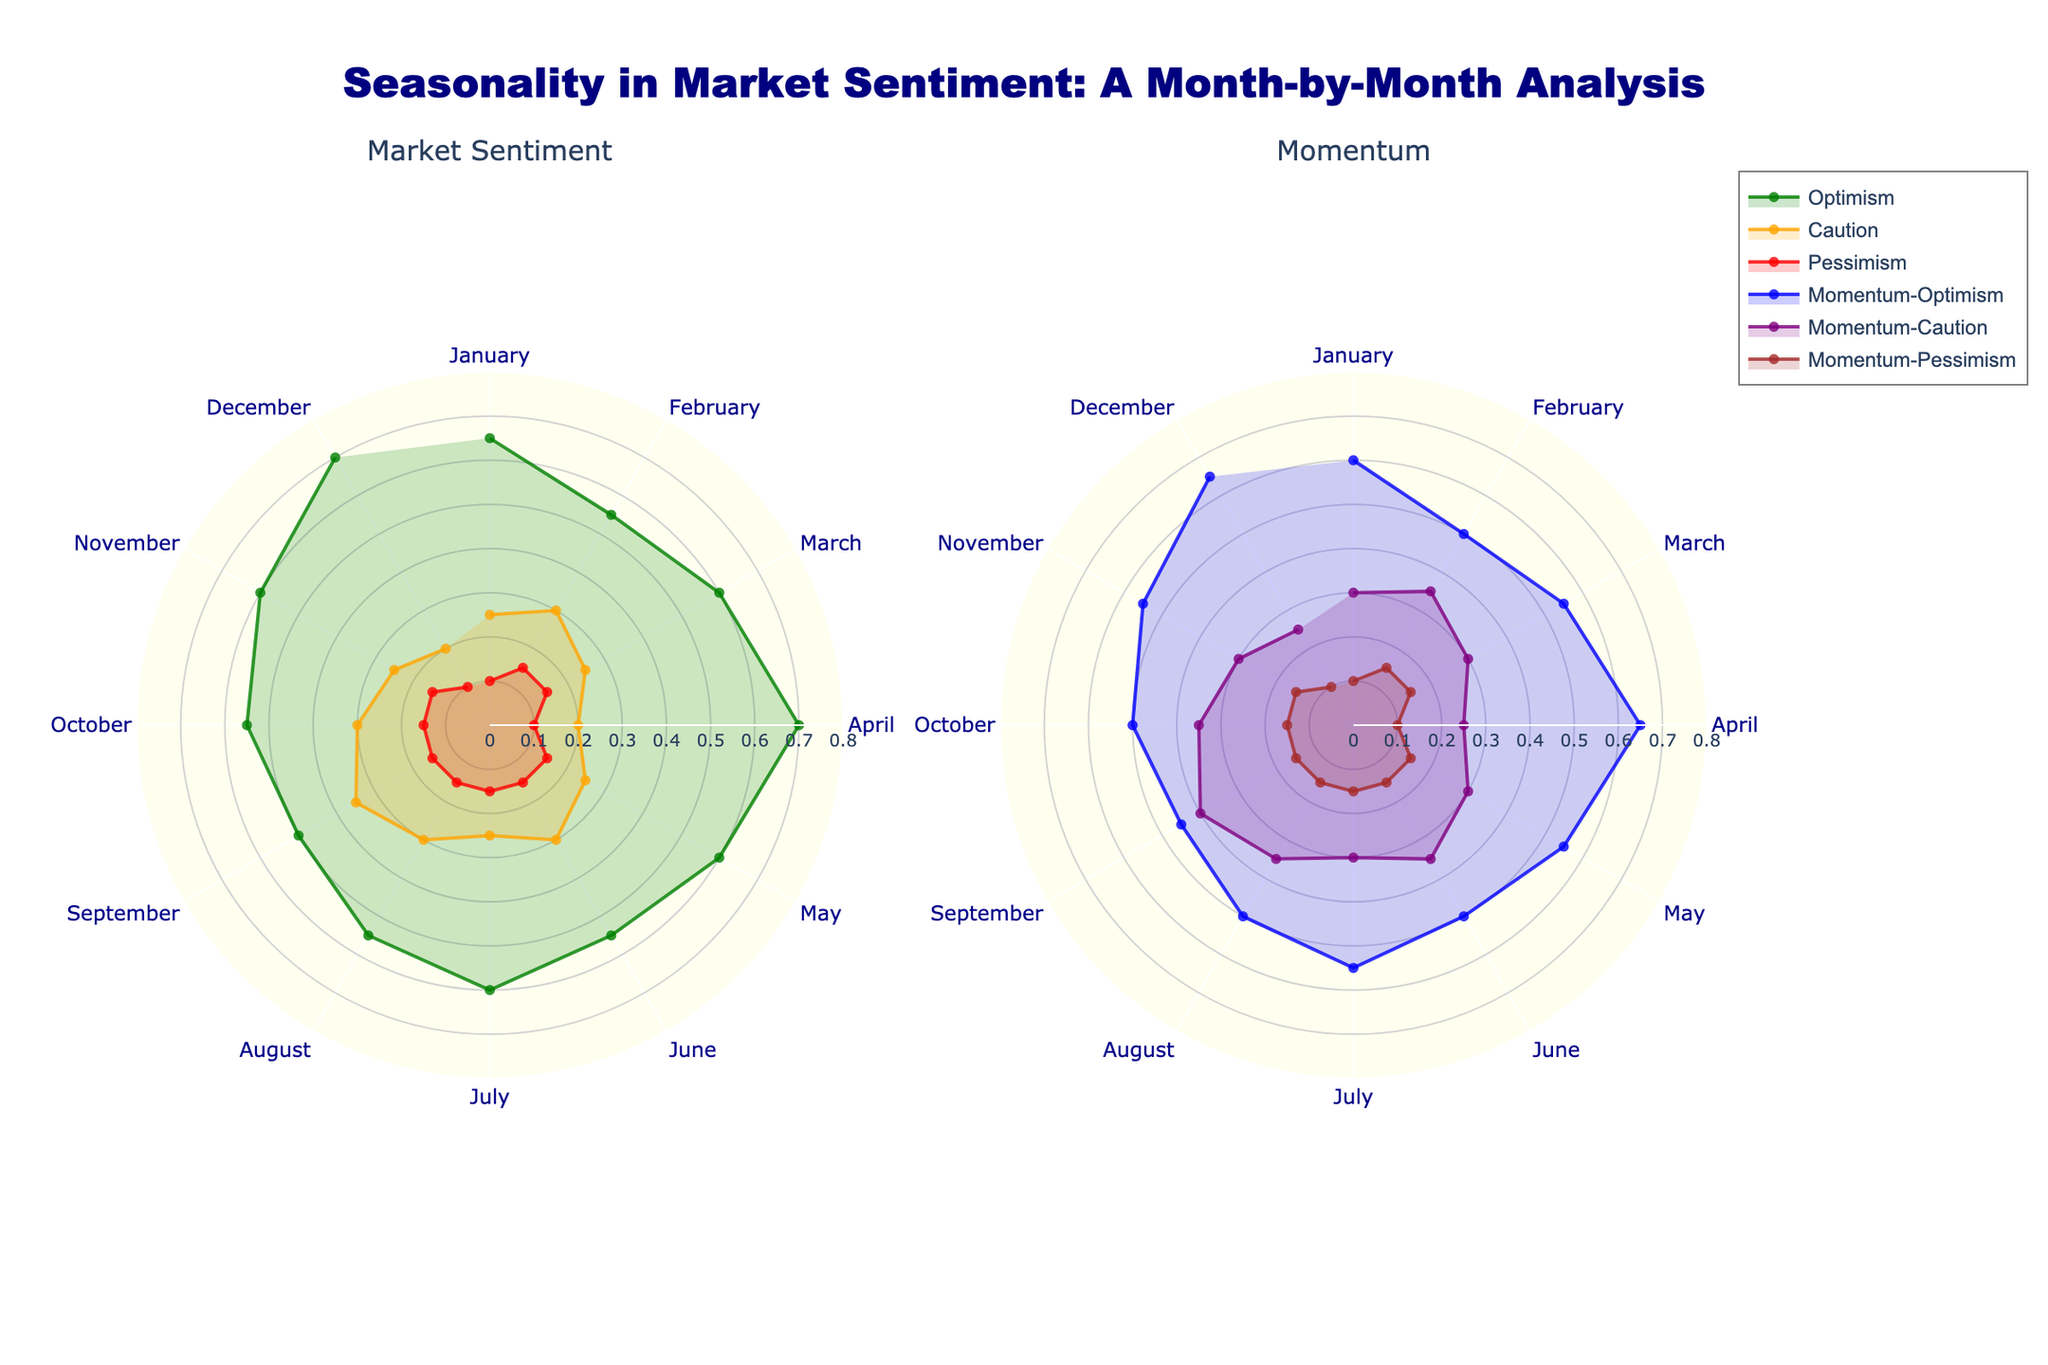What does the title of the figure indicate? The title of the figure, "Seasonality in Market Sentiment: A Month-by-Month Analysis," suggests that the figure examines how market sentiment changes throughout the year, from January to December. It emphasizes a month-by-month analysis and includes views on both sentiment and momentum.
Answer: It analyzes market sentiment seasonally What are the three types of market sentiment analyzed in the figure? The three types of market sentiment analyzed are Optimism, Caution, and Pessimism. These are depicted in the left subplot.
Answer: Optimism, Caution, Pessimism Which month shows the highest level of optimism in both market sentiment and momentum? Both January and December show the highest levels of optimism in market sentiment and momentum. This can be observed as they have the same Optimism value of 0.70 and Momentum-Optimism value of 0.65 in both subplots.
Answer: January and December How does the momentum of Caution compare to Caution in September? In September, Caution has a value of 0.35, while Momentum-Caution has a value of 0.40. This means the momentum of Caution is slightly higher than Caution itself in that month.
Answer: Momentum-Caution is 0.05 higher Which sentiment shows the least variation in its values across all months? Pessimism shows the least variation across all months, with values consistently at 0.10 in several months and 0.15 in most others, suggesting it is relatively stable compared to Optimism and Caution.
Answer: Pessimism In which months is there an equal value of optimism in both market sentiment and momentum? March, May, July, October, and November all have equal levels of Optimism in both market sentiment and momentum at 0.60 for March, July, and November, and 0.55 for May and October.
Answer: March, May, July, October, November Which month shows the highest value of Pessimism in market sentiment, and what are the corresponding Momentum-Pessimism values? Pessimism peaks at 0.15 in several months, such as February, March, May, June, July, August, September, October, and November, with corresponding Momentum-Pessimism values also at 0.15.
Answer: February, March, May, June, July, August, September, October, November (0.15) How does the sentiment pattern of Caution change from winter to summer (December to June)? From December to June, Caution values rise from 0.20 to a peak of 0.30. This gradual increase indicates a growing cautious sentiment as the year progresses into summer.
Answer: Increases from 0.20 to 0.30 Which month has the widest gap between Optimism and Pessimism in market sentiment? April and December both have the widest gap between Optimism (0.70) and Pessimism (0.10), making the difference 0.60.
Answer: April, December Describe the overall trend of Momentum-Caution values throughout the year. Momentum-Caution fluctuates between 0.25 and 0.40, with the lowest values in January, April, and December (0.25) and the highest in September (0.40), indicating variable caution momentum.
Answer: Fluctuates from 0.25 to 0.40 